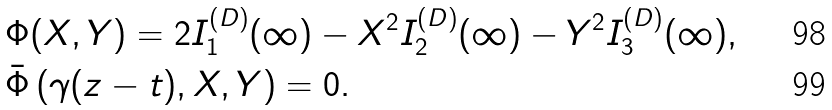Convert formula to latex. <formula><loc_0><loc_0><loc_500><loc_500>& \Phi ( X , Y ) = 2 I ^ { ( D ) } _ { 1 } ( \infty ) - X ^ { 2 } I ^ { ( D ) } _ { 2 } ( \infty ) - Y ^ { 2 } I ^ { ( D ) } _ { 3 } ( \infty ) , \\ & \bar { \Phi } \left ( \gamma ( z - t ) , X , Y \right ) = 0 .</formula> 